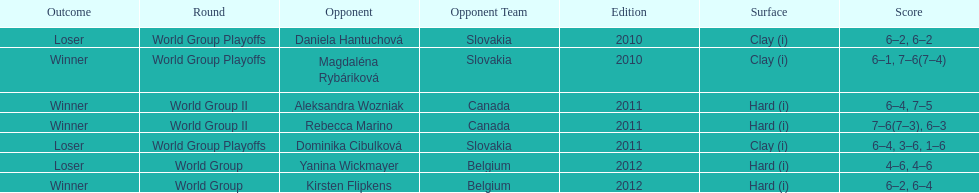Number of games in the match against dominika cibulkova? 3. 